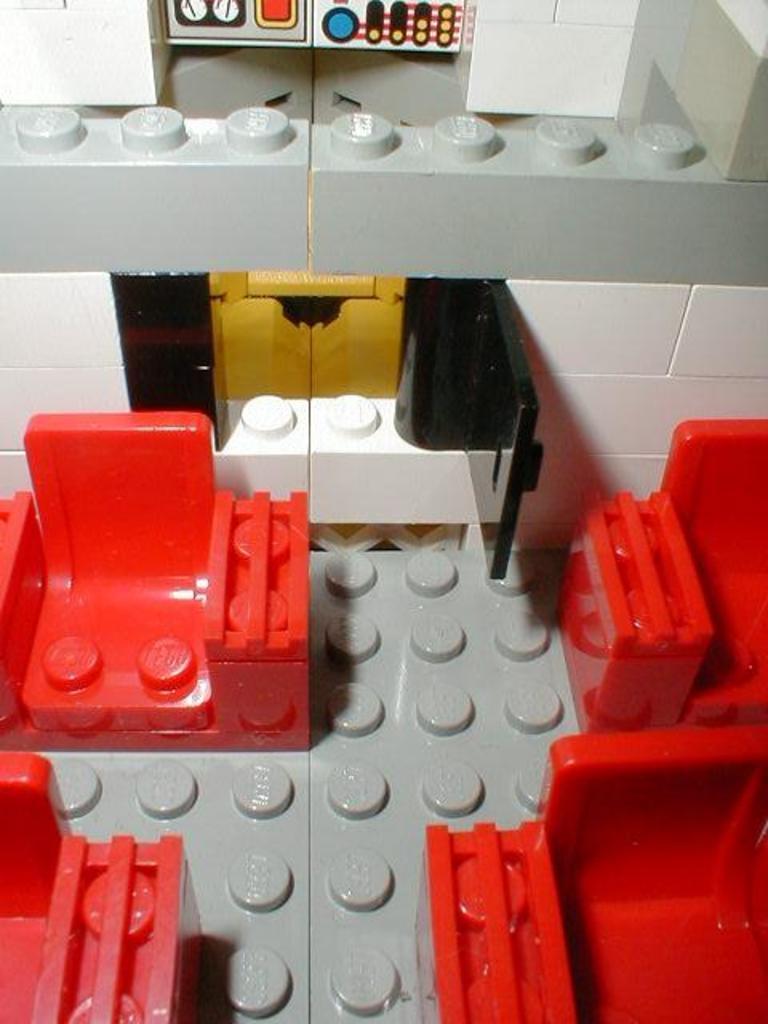How would you summarize this image in a sentence or two? There are lego bricks which are red, grey and white in color. 